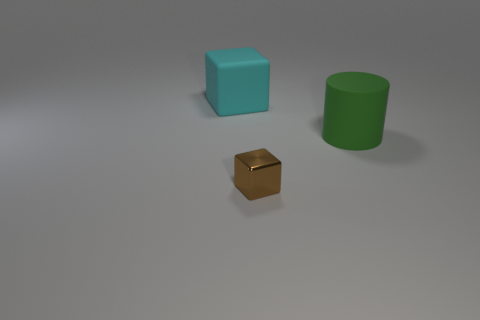There is a thing that is both behind the brown thing and left of the cylinder; what is its shape?
Provide a short and direct response. Cube. There is a brown shiny cube; is its size the same as the rubber thing that is on the right side of the cyan thing?
Offer a terse response. No. The shiny object that is the same shape as the cyan matte object is what color?
Provide a short and direct response. Brown. Does the thing that is to the left of the metallic block have the same size as the object to the right of the tiny metal block?
Offer a very short reply. Yes. Does the cyan object have the same shape as the metal thing?
Your answer should be compact. Yes. What number of objects are either cubes that are behind the big matte cylinder or small red matte spheres?
Provide a succinct answer. 1. Are there any other big green objects of the same shape as the green thing?
Provide a short and direct response. No. Are there the same number of small blocks right of the brown metal block and large green matte objects?
Keep it short and to the point. No. How many brown metal things are the same size as the shiny block?
Your answer should be compact. 0. How many metal cubes are behind the large green object?
Provide a succinct answer. 0. 